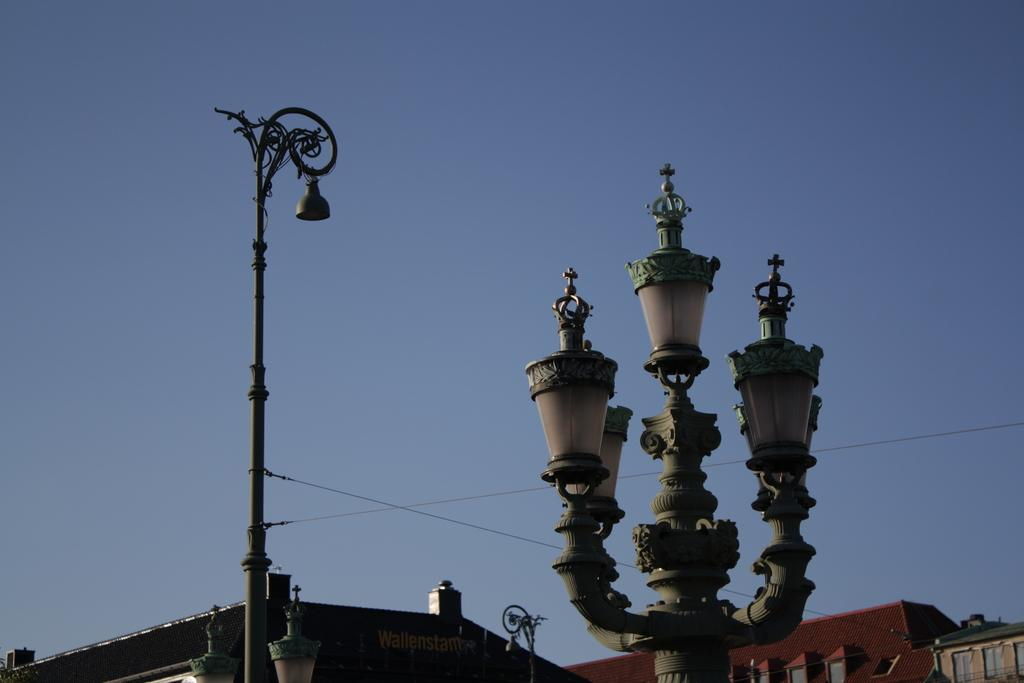What type of structures can be seen in the image? There are buildings in the image. What feature is visible on the buildings? There are windows visible in the image. What objects are present near the buildings? There are poles and lights visible in the image. What else can be seen in the image? Wires are present in the image. What is visible in the background of the image? The sky is visible in the background of the image. How many chickens are perched on the wires in the image? There are no chickens present in the image; it features buildings, windows, poles, lights, wires, and the sky. What type of cable is being used to connect the lights in the image? The image does not provide information about the type of cable used to connect the lights. 